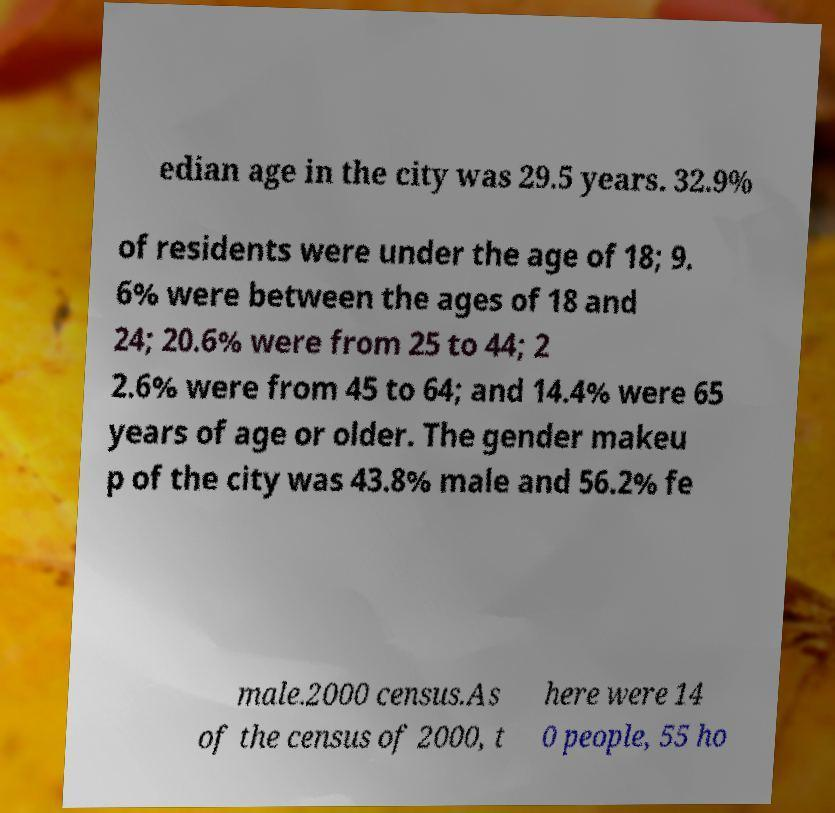Could you assist in decoding the text presented in this image and type it out clearly? edian age in the city was 29.5 years. 32.9% of residents were under the age of 18; 9. 6% were between the ages of 18 and 24; 20.6% were from 25 to 44; 2 2.6% were from 45 to 64; and 14.4% were 65 years of age or older. The gender makeu p of the city was 43.8% male and 56.2% fe male.2000 census.As of the census of 2000, t here were 14 0 people, 55 ho 